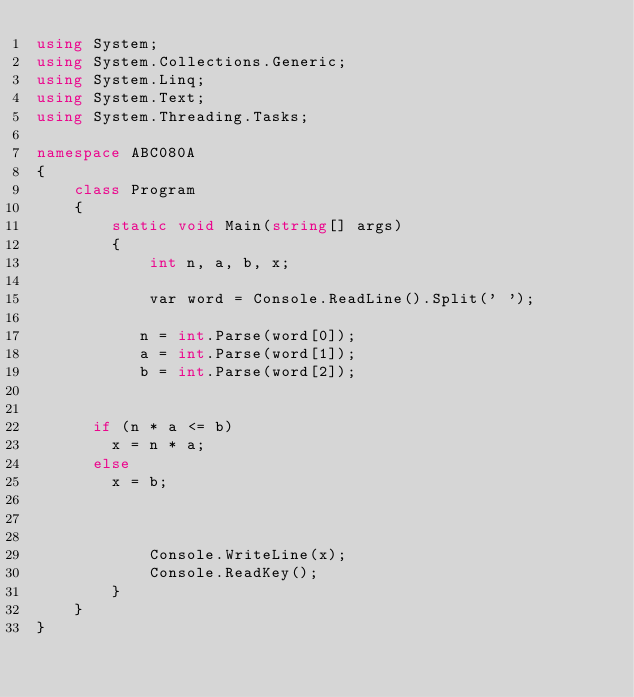<code> <loc_0><loc_0><loc_500><loc_500><_C#_>using System;
using System.Collections.Generic;
using System.Linq;
using System.Text;
using System.Threading.Tasks;

namespace ABC080A
{
    class Program
    {
        static void Main(string[] args)
        {
            int n, a, b, x;

            var word = Console.ReadLine().Split(' ');

           n = int.Parse(word[0]);
           a = int.Parse(word[1]);
           b = int.Parse(word[2]);


			if (n * a <= b)
				x = n * a;
			else
				x = b;
           
             

            Console.WriteLine(x);
            Console.ReadKey();
        }
    }
}
</code> 